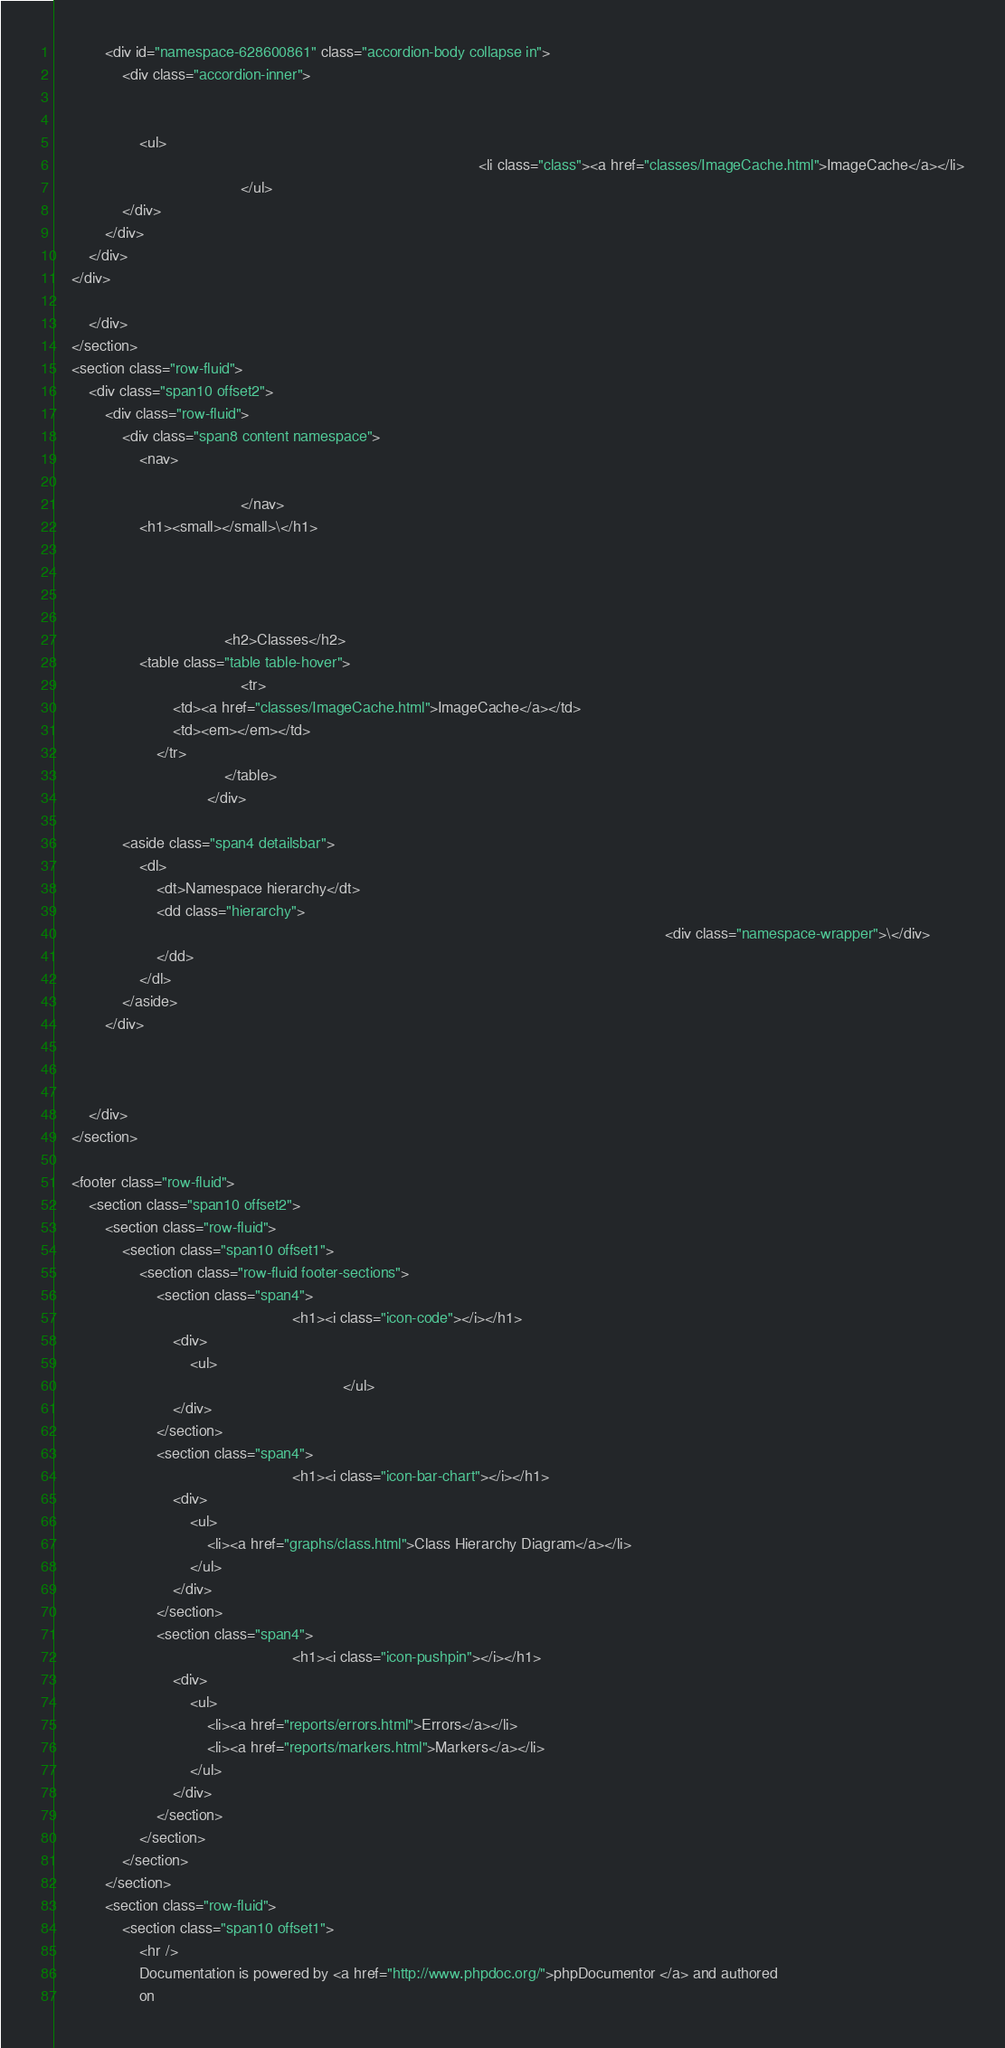Convert code to text. <code><loc_0><loc_0><loc_500><loc_500><_HTML_>            <div id="namespace-628600861" class="accordion-body collapse in">
                <div class="accordion-inner">

                    
                    <ul>
                                                                                                    <li class="class"><a href="classes/ImageCache.html">ImageCache</a></li>
                                            </ul>
                </div>
            </div>
        </div>
    </div>

        </div>
    </section>
    <section class="row-fluid">
        <div class="span10 offset2">
            <div class="row-fluid">
                <div class="span8 content namespace">
                    <nav>
                                                
                                            </nav>
                    <h1><small></small>\</h1>

                    
                    
                    
                                        <h2>Classes</h2>
                    <table class="table table-hover">
                                            <tr>
                            <td><a href="classes/ImageCache.html">ImageCache</a></td>
                            <td><em></em></td>
                        </tr>
                                        </table>
                                    </div>

                <aside class="span4 detailsbar">
                    <dl>
                        <dt>Namespace hierarchy</dt>
                        <dd class="hierarchy">
                                                                                                                                                <div class="namespace-wrapper">\</div>
                        </dd>
                    </dl>
                </aside>
            </div>

            
            
        </div>
    </section>

    <footer class="row-fluid">
        <section class="span10 offset2">
            <section class="row-fluid">
                <section class="span10 offset1">
                    <section class="row-fluid footer-sections">
                        <section class="span4">
                                                        <h1><i class="icon-code"></i></h1>
                            <div>
                                <ul>
                                                                    </ul>
                            </div>
                        </section>
                        <section class="span4">
                                                        <h1><i class="icon-bar-chart"></i></h1>
                            <div>
                                <ul>
                                    <li><a href="graphs/class.html">Class Hierarchy Diagram</a></li>
                                </ul>
                            </div>
                        </section>
                        <section class="span4">
                                                        <h1><i class="icon-pushpin"></i></h1>
                            <div>
                                <ul>
                                    <li><a href="reports/errors.html">Errors</a></li>
                                    <li><a href="reports/markers.html">Markers</a></li>
                                </ul>
                            </div>
                        </section>
                    </section>
                </section>
            </section>
            <section class="row-fluid">
                <section class="span10 offset1">
                    <hr />
                    Documentation is powered by <a href="http://www.phpdoc.org/">phpDocumentor </a> and authored
                    on </code> 